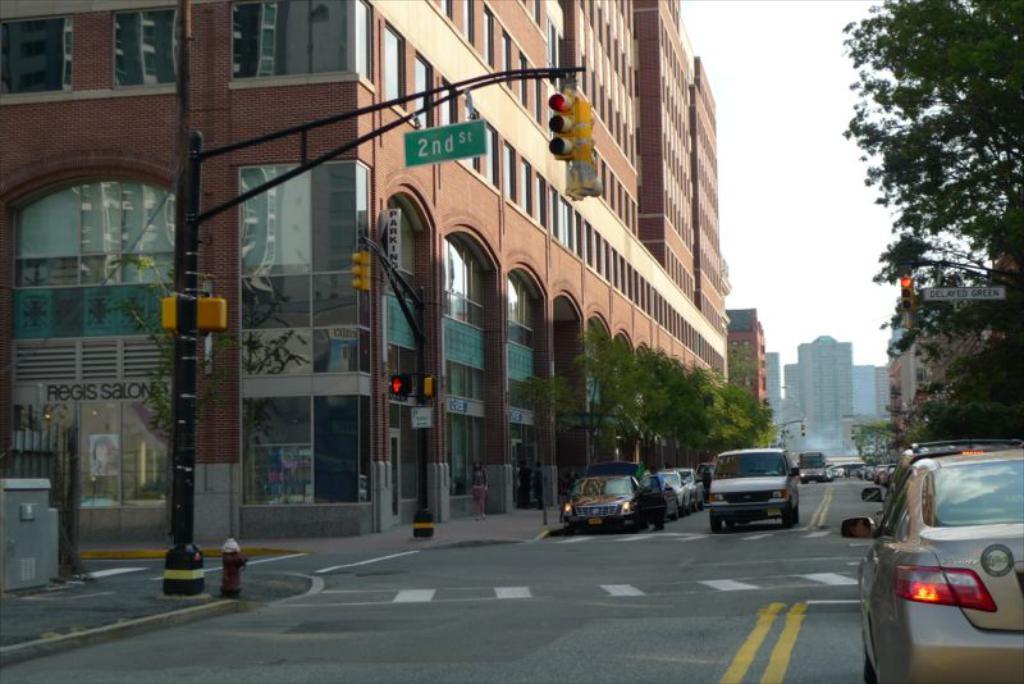Could you give a brief overview of what you see in this image? In the image there is a road and on the road there are vehicles, around the road there are trees, buildings, traffic signal poles. 